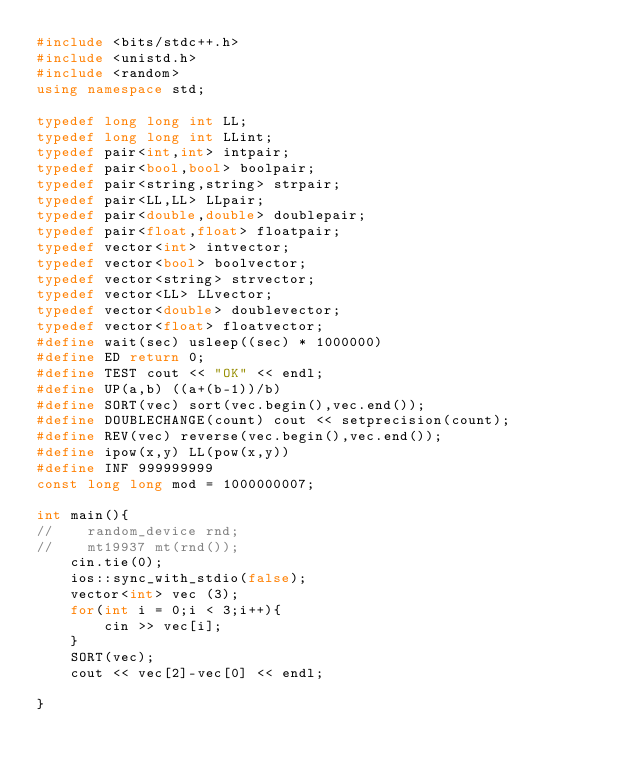Convert code to text. <code><loc_0><loc_0><loc_500><loc_500><_C++_>#include <bits/stdc++.h>
#include <unistd.h>
#include <random>
using namespace std;

typedef long long int LL;
typedef long long int LLint;
typedef pair<int,int> intpair;
typedef pair<bool,bool> boolpair;
typedef pair<string,string> strpair;
typedef pair<LL,LL> LLpair;
typedef pair<double,double> doublepair;
typedef pair<float,float> floatpair;
typedef vector<int> intvector;
typedef vector<bool> boolvector;
typedef vector<string> strvector;
typedef vector<LL> LLvector;
typedef vector<double> doublevector;
typedef vector<float> floatvector;
#define wait(sec) usleep((sec) * 1000000)
#define ED return 0;
#define TEST cout << "OK" << endl;
#define UP(a,b) ((a+(b-1))/b)
#define SORT(vec) sort(vec.begin(),vec.end());
#define DOUBLECHANGE(count) cout << setprecision(count);
#define REV(vec) reverse(vec.begin(),vec.end());
#define ipow(x,y) LL(pow(x,y))
#define INF 999999999
const long long mod = 1000000007;

int main(){
//    random_device rnd;
//    mt19937 mt(rnd());
    cin.tie(0);
    ios::sync_with_stdio(false);
    vector<int> vec (3);
    for(int i = 0;i < 3;i++){
        cin >> vec[i];
    }
    SORT(vec);
    cout << vec[2]-vec[0] << endl;
    
}
</code> 